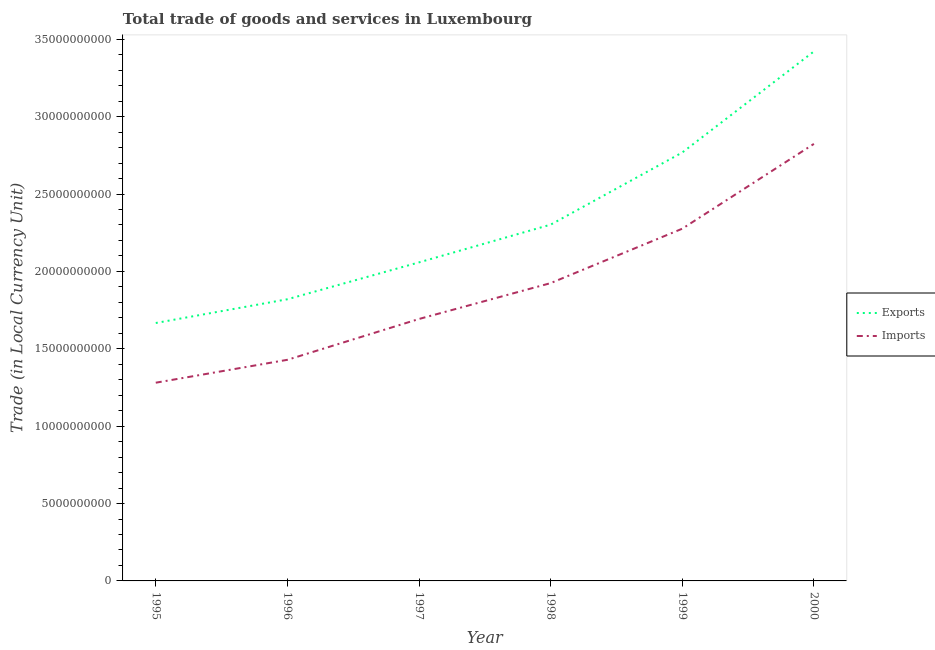How many different coloured lines are there?
Your response must be concise. 2. Does the line corresponding to imports of goods and services intersect with the line corresponding to export of goods and services?
Provide a short and direct response. No. Is the number of lines equal to the number of legend labels?
Your answer should be very brief. Yes. What is the export of goods and services in 2000?
Your answer should be compact. 3.42e+1. Across all years, what is the maximum export of goods and services?
Make the answer very short. 3.42e+1. Across all years, what is the minimum export of goods and services?
Your answer should be compact. 1.67e+1. What is the total export of goods and services in the graph?
Your answer should be compact. 1.40e+11. What is the difference between the export of goods and services in 1999 and that in 2000?
Make the answer very short. -6.53e+09. What is the difference between the imports of goods and services in 1995 and the export of goods and services in 2000?
Offer a very short reply. -2.14e+1. What is the average export of goods and services per year?
Your answer should be compact. 2.34e+1. In the year 1997, what is the difference between the export of goods and services and imports of goods and services?
Keep it short and to the point. 3.66e+09. What is the ratio of the export of goods and services in 1995 to that in 1996?
Provide a succinct answer. 0.92. Is the imports of goods and services in 1996 less than that in 2000?
Ensure brevity in your answer.  Yes. Is the difference between the imports of goods and services in 1996 and 1998 greater than the difference between the export of goods and services in 1996 and 1998?
Provide a succinct answer. No. What is the difference between the highest and the second highest export of goods and services?
Ensure brevity in your answer.  6.53e+09. What is the difference between the highest and the lowest imports of goods and services?
Your answer should be very brief. 1.54e+1. Is the sum of the imports of goods and services in 1999 and 2000 greater than the maximum export of goods and services across all years?
Give a very brief answer. Yes. Is the export of goods and services strictly greater than the imports of goods and services over the years?
Your answer should be very brief. Yes. How many lines are there?
Your response must be concise. 2. How many years are there in the graph?
Provide a succinct answer. 6. Does the graph contain grids?
Keep it short and to the point. No. Where does the legend appear in the graph?
Make the answer very short. Center right. How many legend labels are there?
Your answer should be very brief. 2. How are the legend labels stacked?
Provide a succinct answer. Vertical. What is the title of the graph?
Offer a very short reply. Total trade of goods and services in Luxembourg. Does "Current education expenditure" appear as one of the legend labels in the graph?
Give a very brief answer. No. What is the label or title of the Y-axis?
Offer a terse response. Trade (in Local Currency Unit). What is the Trade (in Local Currency Unit) of Exports in 1995?
Make the answer very short. 1.67e+1. What is the Trade (in Local Currency Unit) of Imports in 1995?
Keep it short and to the point. 1.28e+1. What is the Trade (in Local Currency Unit) of Exports in 1996?
Your answer should be compact. 1.82e+1. What is the Trade (in Local Currency Unit) in Imports in 1996?
Keep it short and to the point. 1.43e+1. What is the Trade (in Local Currency Unit) in Exports in 1997?
Give a very brief answer. 2.06e+1. What is the Trade (in Local Currency Unit) in Imports in 1997?
Provide a succinct answer. 1.69e+1. What is the Trade (in Local Currency Unit) in Exports in 1998?
Provide a succinct answer. 2.30e+1. What is the Trade (in Local Currency Unit) in Imports in 1998?
Make the answer very short. 1.92e+1. What is the Trade (in Local Currency Unit) of Exports in 1999?
Give a very brief answer. 2.77e+1. What is the Trade (in Local Currency Unit) of Imports in 1999?
Provide a short and direct response. 2.28e+1. What is the Trade (in Local Currency Unit) in Exports in 2000?
Your response must be concise. 3.42e+1. What is the Trade (in Local Currency Unit) in Imports in 2000?
Your response must be concise. 2.82e+1. Across all years, what is the maximum Trade (in Local Currency Unit) of Exports?
Your response must be concise. 3.42e+1. Across all years, what is the maximum Trade (in Local Currency Unit) in Imports?
Provide a succinct answer. 2.82e+1. Across all years, what is the minimum Trade (in Local Currency Unit) of Exports?
Provide a short and direct response. 1.67e+1. Across all years, what is the minimum Trade (in Local Currency Unit) of Imports?
Offer a very short reply. 1.28e+1. What is the total Trade (in Local Currency Unit) of Exports in the graph?
Give a very brief answer. 1.40e+11. What is the total Trade (in Local Currency Unit) of Imports in the graph?
Your answer should be very brief. 1.14e+11. What is the difference between the Trade (in Local Currency Unit) in Exports in 1995 and that in 1996?
Offer a terse response. -1.53e+09. What is the difference between the Trade (in Local Currency Unit) in Imports in 1995 and that in 1996?
Provide a succinct answer. -1.48e+09. What is the difference between the Trade (in Local Currency Unit) of Exports in 1995 and that in 1997?
Offer a terse response. -3.92e+09. What is the difference between the Trade (in Local Currency Unit) in Imports in 1995 and that in 1997?
Provide a short and direct response. -4.12e+09. What is the difference between the Trade (in Local Currency Unit) in Exports in 1995 and that in 1998?
Make the answer very short. -6.36e+09. What is the difference between the Trade (in Local Currency Unit) in Imports in 1995 and that in 1998?
Make the answer very short. -6.44e+09. What is the difference between the Trade (in Local Currency Unit) of Exports in 1995 and that in 1999?
Offer a terse response. -1.10e+1. What is the difference between the Trade (in Local Currency Unit) in Imports in 1995 and that in 1999?
Give a very brief answer. -9.95e+09. What is the difference between the Trade (in Local Currency Unit) of Exports in 1995 and that in 2000?
Provide a succinct answer. -1.75e+1. What is the difference between the Trade (in Local Currency Unit) of Imports in 1995 and that in 2000?
Make the answer very short. -1.54e+1. What is the difference between the Trade (in Local Currency Unit) of Exports in 1996 and that in 1997?
Your response must be concise. -2.38e+09. What is the difference between the Trade (in Local Currency Unit) in Imports in 1996 and that in 1997?
Provide a short and direct response. -2.64e+09. What is the difference between the Trade (in Local Currency Unit) of Exports in 1996 and that in 1998?
Offer a terse response. -4.82e+09. What is the difference between the Trade (in Local Currency Unit) in Imports in 1996 and that in 1998?
Ensure brevity in your answer.  -4.96e+09. What is the difference between the Trade (in Local Currency Unit) of Exports in 1996 and that in 1999?
Give a very brief answer. -9.48e+09. What is the difference between the Trade (in Local Currency Unit) of Imports in 1996 and that in 1999?
Your answer should be very brief. -8.47e+09. What is the difference between the Trade (in Local Currency Unit) in Exports in 1996 and that in 2000?
Your answer should be compact. -1.60e+1. What is the difference between the Trade (in Local Currency Unit) in Imports in 1996 and that in 2000?
Offer a very short reply. -1.40e+1. What is the difference between the Trade (in Local Currency Unit) of Exports in 1997 and that in 1998?
Provide a short and direct response. -2.44e+09. What is the difference between the Trade (in Local Currency Unit) in Imports in 1997 and that in 1998?
Offer a very short reply. -2.32e+09. What is the difference between the Trade (in Local Currency Unit) in Exports in 1997 and that in 1999?
Provide a short and direct response. -7.10e+09. What is the difference between the Trade (in Local Currency Unit) of Imports in 1997 and that in 1999?
Ensure brevity in your answer.  -5.83e+09. What is the difference between the Trade (in Local Currency Unit) in Exports in 1997 and that in 2000?
Ensure brevity in your answer.  -1.36e+1. What is the difference between the Trade (in Local Currency Unit) of Imports in 1997 and that in 2000?
Offer a very short reply. -1.13e+1. What is the difference between the Trade (in Local Currency Unit) in Exports in 1998 and that in 1999?
Your answer should be very brief. -4.66e+09. What is the difference between the Trade (in Local Currency Unit) of Imports in 1998 and that in 1999?
Ensure brevity in your answer.  -3.52e+09. What is the difference between the Trade (in Local Currency Unit) in Exports in 1998 and that in 2000?
Your response must be concise. -1.12e+1. What is the difference between the Trade (in Local Currency Unit) in Imports in 1998 and that in 2000?
Your answer should be very brief. -9.00e+09. What is the difference between the Trade (in Local Currency Unit) of Exports in 1999 and that in 2000?
Your response must be concise. -6.53e+09. What is the difference between the Trade (in Local Currency Unit) in Imports in 1999 and that in 2000?
Offer a very short reply. -5.48e+09. What is the difference between the Trade (in Local Currency Unit) in Exports in 1995 and the Trade (in Local Currency Unit) in Imports in 1996?
Your answer should be compact. 2.38e+09. What is the difference between the Trade (in Local Currency Unit) in Exports in 1995 and the Trade (in Local Currency Unit) in Imports in 1997?
Your answer should be compact. -2.60e+08. What is the difference between the Trade (in Local Currency Unit) in Exports in 1995 and the Trade (in Local Currency Unit) in Imports in 1998?
Ensure brevity in your answer.  -2.58e+09. What is the difference between the Trade (in Local Currency Unit) of Exports in 1995 and the Trade (in Local Currency Unit) of Imports in 1999?
Offer a terse response. -6.09e+09. What is the difference between the Trade (in Local Currency Unit) in Exports in 1995 and the Trade (in Local Currency Unit) in Imports in 2000?
Offer a very short reply. -1.16e+1. What is the difference between the Trade (in Local Currency Unit) of Exports in 1996 and the Trade (in Local Currency Unit) of Imports in 1997?
Offer a very short reply. 1.27e+09. What is the difference between the Trade (in Local Currency Unit) in Exports in 1996 and the Trade (in Local Currency Unit) in Imports in 1998?
Offer a very short reply. -1.04e+09. What is the difference between the Trade (in Local Currency Unit) in Exports in 1996 and the Trade (in Local Currency Unit) in Imports in 1999?
Give a very brief answer. -4.56e+09. What is the difference between the Trade (in Local Currency Unit) in Exports in 1996 and the Trade (in Local Currency Unit) in Imports in 2000?
Give a very brief answer. -1.00e+1. What is the difference between the Trade (in Local Currency Unit) of Exports in 1997 and the Trade (in Local Currency Unit) of Imports in 1998?
Make the answer very short. 1.34e+09. What is the difference between the Trade (in Local Currency Unit) of Exports in 1997 and the Trade (in Local Currency Unit) of Imports in 1999?
Offer a terse response. -2.18e+09. What is the difference between the Trade (in Local Currency Unit) in Exports in 1997 and the Trade (in Local Currency Unit) in Imports in 2000?
Make the answer very short. -7.66e+09. What is the difference between the Trade (in Local Currency Unit) of Exports in 1998 and the Trade (in Local Currency Unit) of Imports in 1999?
Your answer should be very brief. 2.62e+08. What is the difference between the Trade (in Local Currency Unit) in Exports in 1998 and the Trade (in Local Currency Unit) in Imports in 2000?
Offer a terse response. -5.22e+09. What is the difference between the Trade (in Local Currency Unit) of Exports in 1999 and the Trade (in Local Currency Unit) of Imports in 2000?
Your response must be concise. -5.56e+08. What is the average Trade (in Local Currency Unit) in Exports per year?
Offer a terse response. 2.34e+1. What is the average Trade (in Local Currency Unit) of Imports per year?
Keep it short and to the point. 1.90e+1. In the year 1995, what is the difference between the Trade (in Local Currency Unit) in Exports and Trade (in Local Currency Unit) in Imports?
Your response must be concise. 3.86e+09. In the year 1996, what is the difference between the Trade (in Local Currency Unit) of Exports and Trade (in Local Currency Unit) of Imports?
Ensure brevity in your answer.  3.91e+09. In the year 1997, what is the difference between the Trade (in Local Currency Unit) of Exports and Trade (in Local Currency Unit) of Imports?
Give a very brief answer. 3.66e+09. In the year 1998, what is the difference between the Trade (in Local Currency Unit) of Exports and Trade (in Local Currency Unit) of Imports?
Provide a short and direct response. 3.78e+09. In the year 1999, what is the difference between the Trade (in Local Currency Unit) in Exports and Trade (in Local Currency Unit) in Imports?
Your response must be concise. 4.92e+09. In the year 2000, what is the difference between the Trade (in Local Currency Unit) in Exports and Trade (in Local Currency Unit) in Imports?
Your response must be concise. 5.97e+09. What is the ratio of the Trade (in Local Currency Unit) in Exports in 1995 to that in 1996?
Your answer should be compact. 0.92. What is the ratio of the Trade (in Local Currency Unit) of Imports in 1995 to that in 1996?
Provide a succinct answer. 0.9. What is the ratio of the Trade (in Local Currency Unit) of Exports in 1995 to that in 1997?
Offer a terse response. 0.81. What is the ratio of the Trade (in Local Currency Unit) in Imports in 1995 to that in 1997?
Your answer should be very brief. 0.76. What is the ratio of the Trade (in Local Currency Unit) in Exports in 1995 to that in 1998?
Offer a terse response. 0.72. What is the ratio of the Trade (in Local Currency Unit) of Imports in 1995 to that in 1998?
Keep it short and to the point. 0.67. What is the ratio of the Trade (in Local Currency Unit) of Exports in 1995 to that in 1999?
Provide a short and direct response. 0.6. What is the ratio of the Trade (in Local Currency Unit) in Imports in 1995 to that in 1999?
Your response must be concise. 0.56. What is the ratio of the Trade (in Local Currency Unit) in Exports in 1995 to that in 2000?
Your response must be concise. 0.49. What is the ratio of the Trade (in Local Currency Unit) of Imports in 1995 to that in 2000?
Your answer should be compact. 0.45. What is the ratio of the Trade (in Local Currency Unit) of Exports in 1996 to that in 1997?
Your answer should be compact. 0.88. What is the ratio of the Trade (in Local Currency Unit) of Imports in 1996 to that in 1997?
Provide a short and direct response. 0.84. What is the ratio of the Trade (in Local Currency Unit) in Exports in 1996 to that in 1998?
Provide a succinct answer. 0.79. What is the ratio of the Trade (in Local Currency Unit) in Imports in 1996 to that in 1998?
Your answer should be compact. 0.74. What is the ratio of the Trade (in Local Currency Unit) in Exports in 1996 to that in 1999?
Your response must be concise. 0.66. What is the ratio of the Trade (in Local Currency Unit) of Imports in 1996 to that in 1999?
Ensure brevity in your answer.  0.63. What is the ratio of the Trade (in Local Currency Unit) in Exports in 1996 to that in 2000?
Keep it short and to the point. 0.53. What is the ratio of the Trade (in Local Currency Unit) of Imports in 1996 to that in 2000?
Ensure brevity in your answer.  0.51. What is the ratio of the Trade (in Local Currency Unit) of Exports in 1997 to that in 1998?
Provide a succinct answer. 0.89. What is the ratio of the Trade (in Local Currency Unit) of Imports in 1997 to that in 1998?
Give a very brief answer. 0.88. What is the ratio of the Trade (in Local Currency Unit) of Exports in 1997 to that in 1999?
Your response must be concise. 0.74. What is the ratio of the Trade (in Local Currency Unit) in Imports in 1997 to that in 1999?
Provide a succinct answer. 0.74. What is the ratio of the Trade (in Local Currency Unit) in Exports in 1997 to that in 2000?
Keep it short and to the point. 0.6. What is the ratio of the Trade (in Local Currency Unit) in Imports in 1997 to that in 2000?
Provide a short and direct response. 0.6. What is the ratio of the Trade (in Local Currency Unit) of Exports in 1998 to that in 1999?
Offer a terse response. 0.83. What is the ratio of the Trade (in Local Currency Unit) in Imports in 1998 to that in 1999?
Provide a succinct answer. 0.85. What is the ratio of the Trade (in Local Currency Unit) of Exports in 1998 to that in 2000?
Offer a very short reply. 0.67. What is the ratio of the Trade (in Local Currency Unit) in Imports in 1998 to that in 2000?
Your answer should be very brief. 0.68. What is the ratio of the Trade (in Local Currency Unit) in Exports in 1999 to that in 2000?
Your response must be concise. 0.81. What is the ratio of the Trade (in Local Currency Unit) in Imports in 1999 to that in 2000?
Offer a very short reply. 0.81. What is the difference between the highest and the second highest Trade (in Local Currency Unit) of Exports?
Keep it short and to the point. 6.53e+09. What is the difference between the highest and the second highest Trade (in Local Currency Unit) in Imports?
Ensure brevity in your answer.  5.48e+09. What is the difference between the highest and the lowest Trade (in Local Currency Unit) of Exports?
Your answer should be very brief. 1.75e+1. What is the difference between the highest and the lowest Trade (in Local Currency Unit) in Imports?
Provide a short and direct response. 1.54e+1. 